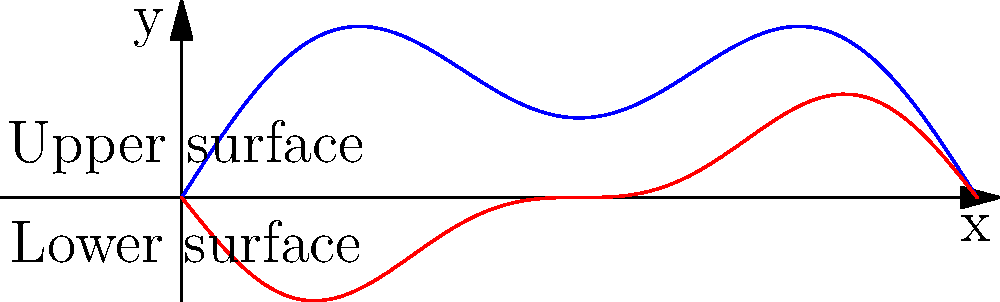Consider the aerodynamic profile of an airfoil represented by the cross-sectional curve shown above. The upper and lower surfaces are described by the functions:

$$f(x) = 0.2\sin(\pi x) + 0.1\sin(3\pi x)$$
$$g(x) = -0.1\sin(2\pi x) - 0.05\sin(4\pi x)$$

where $x \in [0,1]$. The pressure distribution along the airfoil is given by:

$$p(x) = p_0 + \rho v^2 \left(\frac{df}{dx} - \frac{dg}{dx}\right)^2$$

where $p_0$ is the ambient pressure, $\rho$ is the air density, and $v$ is the airspeed. 

Using your expertise in interpolation and approximation theory, what numerical method would you recommend to find the optimal value of $x$ that maximizes the pressure difference between the upper and lower surfaces, and why? To solve this optimization problem, we need to consider the following steps:

1) First, we need to calculate the derivatives of $f(x)$ and $g(x)$:
   $$\frac{df}{dx} = 0.2\pi\cos(\pi x) + 0.3\pi\cos(3\pi x)$$
   $$\frac{dg}{dx} = -0.2\pi\cos(2\pi x) - 0.2\pi\cos(4\pi x)$$

2) The pressure difference $\Delta p(x)$ between the upper and lower surfaces is:
   $$\Delta p(x) = \rho v^2 \left(\frac{df}{dx} - \frac{dg}{dx}\right)^2$$

3) Our goal is to maximize $\Delta p(x)$ over the interval $[0,1]$.

4) Given the complexity of the function, analytical methods may be challenging. A numerical approach would be more suitable.

5) Considering the persona of a mathematics professor specializing in interpolation and approximation theory, an effective method would be the Chebyshev approximation combined with Newton's method.

6) The Chebyshev approximation can be used to create a polynomial interpolation of $\Delta p(x)$ over $[0,1]$. This approximation will be highly accurate due to the minimization of the maximum error.

7) Once we have the Chebyshev approximation, we can use Newton's method to find the maximum of this approximation. Newton's method is particularly effective for smooth functions, which our approximation will be.

8) The Chebyshev nodes can be used as initial guesses for Newton's method, increasing the likelihood of finding the global maximum.

9) This combined approach leverages the strengths of both interpolation (Chebyshev) and optimization (Newton's method) techniques, aligning well with the expertise of the persona.
Answer: Chebyshev approximation combined with Newton's method 